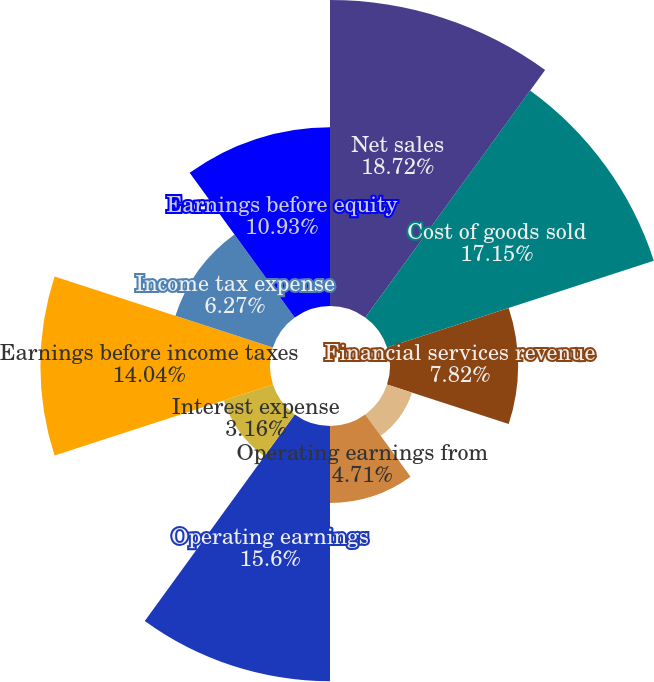Convert chart to OTSL. <chart><loc_0><loc_0><loc_500><loc_500><pie_chart><fcel>Net sales<fcel>Cost of goods sold<fcel>Financial services revenue<fcel>Financial services expenses<fcel>Operating earnings from<fcel>Operating earnings<fcel>Interest expense<fcel>Earnings before income taxes<fcel>Income tax expense<fcel>Earnings before equity<nl><fcel>18.71%<fcel>17.15%<fcel>7.82%<fcel>1.6%<fcel>4.71%<fcel>15.6%<fcel>3.16%<fcel>14.04%<fcel>6.27%<fcel>10.93%<nl></chart> 